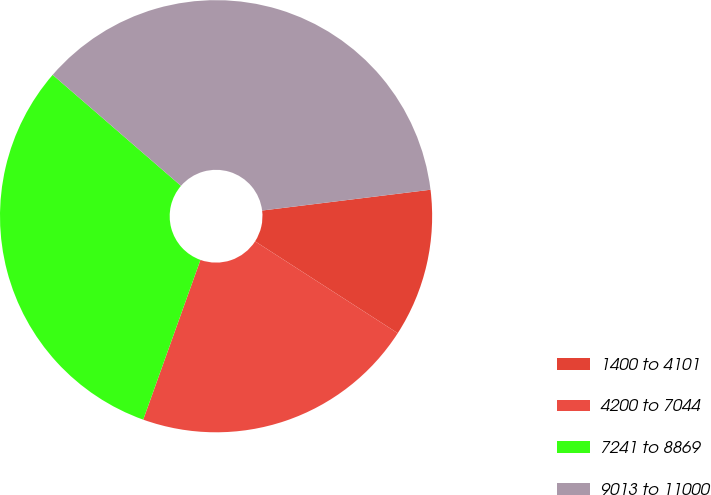<chart> <loc_0><loc_0><loc_500><loc_500><pie_chart><fcel>1400 to 4101<fcel>4200 to 7044<fcel>7241 to 8869<fcel>9013 to 11000<nl><fcel>11.06%<fcel>21.37%<fcel>30.88%<fcel>36.69%<nl></chart> 